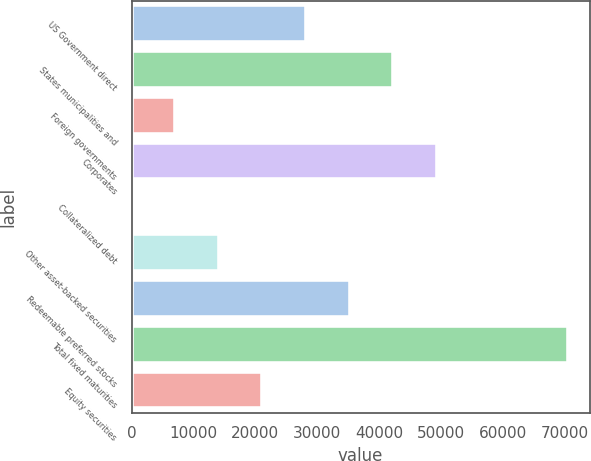<chart> <loc_0><loc_0><loc_500><loc_500><bar_chart><fcel>US Government direct<fcel>States municipalities and<fcel>Foreign governments<fcel>Corporates<fcel>Collateralized debt<fcel>Other asset-backed securities<fcel>Redeemable preferred stocks<fcel>Total fixed maturities<fcel>Equity securities<nl><fcel>28185.8<fcel>42278.5<fcel>7046.74<fcel>49324.9<fcel>0.38<fcel>14093.1<fcel>35232.2<fcel>70464<fcel>21139.5<nl></chart> 